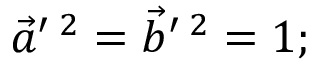<formula> <loc_0><loc_0><loc_500><loc_500>\vec { a } ^ { \prime \, 2 } = \vec { b } ^ { \prime \, 2 } = 1 ;</formula> 